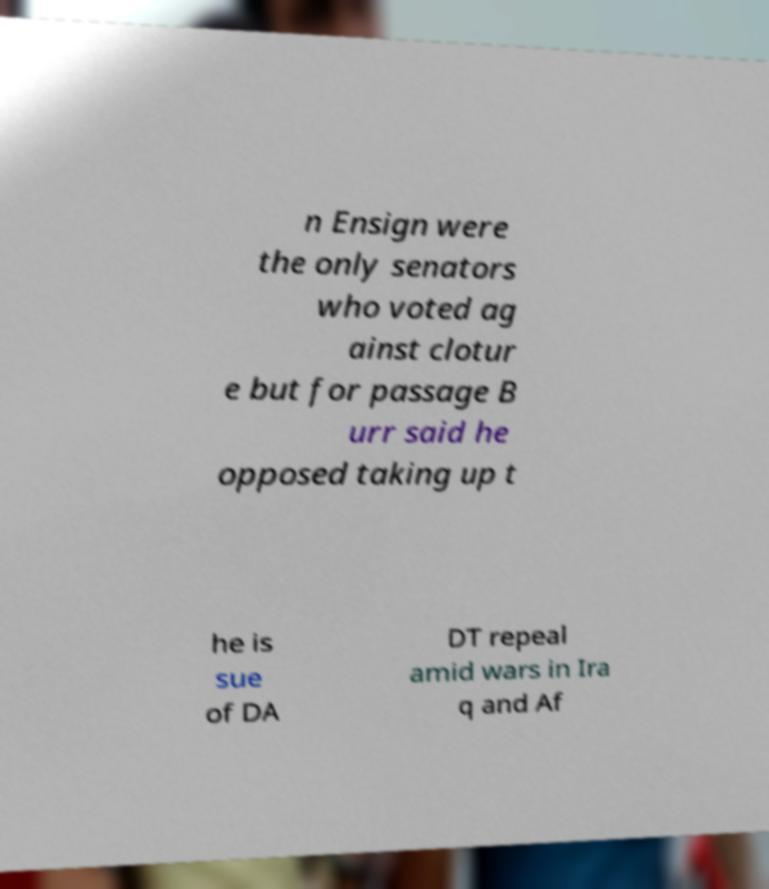Can you read and provide the text displayed in the image?This photo seems to have some interesting text. Can you extract and type it out for me? n Ensign were the only senators who voted ag ainst clotur e but for passage B urr said he opposed taking up t he is sue of DA DT repeal amid wars in Ira q and Af 